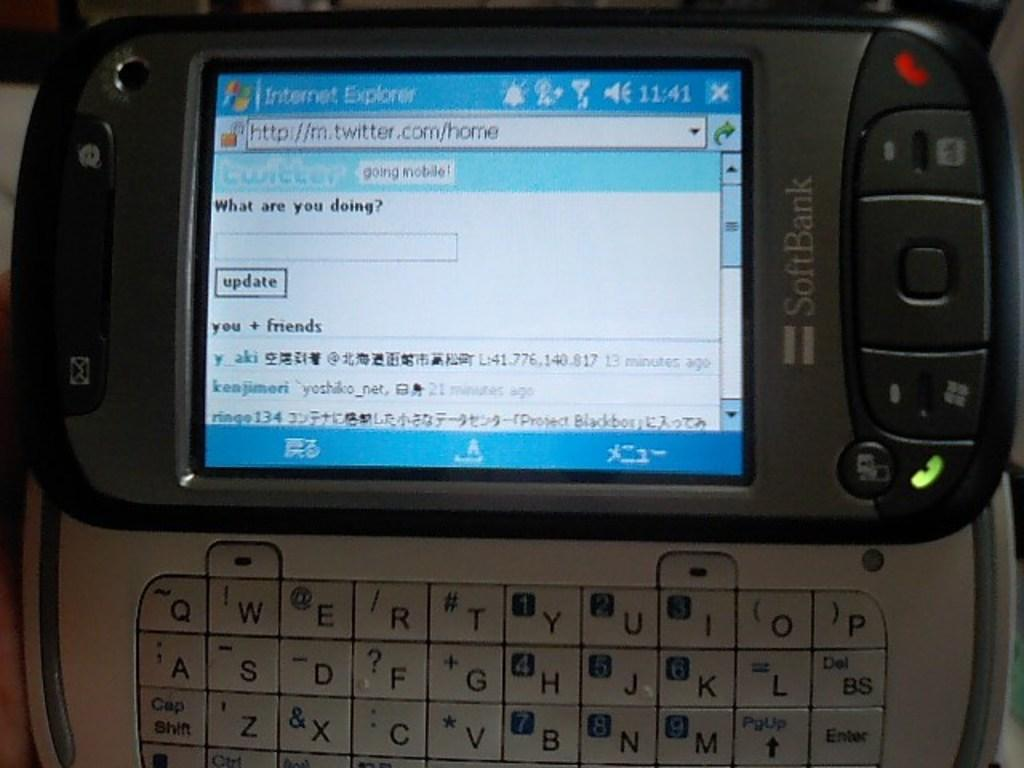<image>
Render a clear and concise summary of the photo. a website on a phone that says internet explorer 